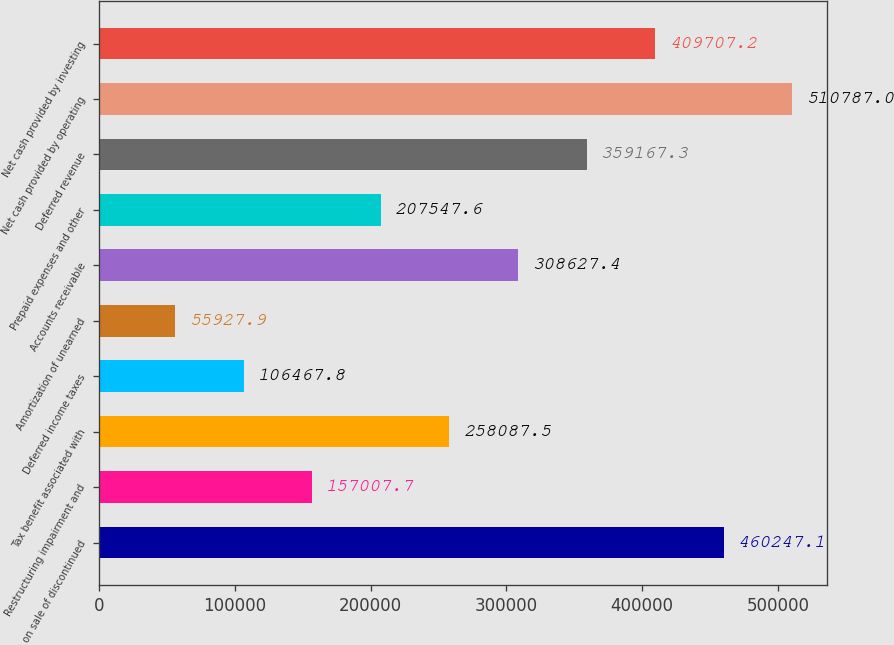<chart> <loc_0><loc_0><loc_500><loc_500><bar_chart><fcel>Gain on sale of discontinued<fcel>Restructuring impairment and<fcel>Tax benefit associated with<fcel>Deferred income taxes<fcel>Amortization of unearned<fcel>Accounts receivable<fcel>Prepaid expenses and other<fcel>Deferred revenue<fcel>Net cash provided by operating<fcel>Net cash provided by investing<nl><fcel>460247<fcel>157008<fcel>258088<fcel>106468<fcel>55927.9<fcel>308627<fcel>207548<fcel>359167<fcel>510787<fcel>409707<nl></chart> 